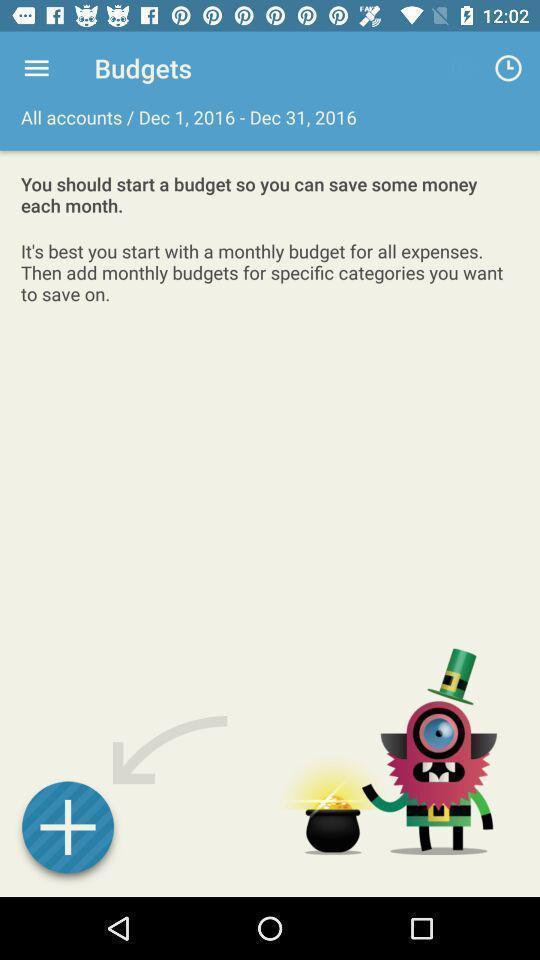Describe the visual elements of this screenshot. Page showing to add budgets on an app. 